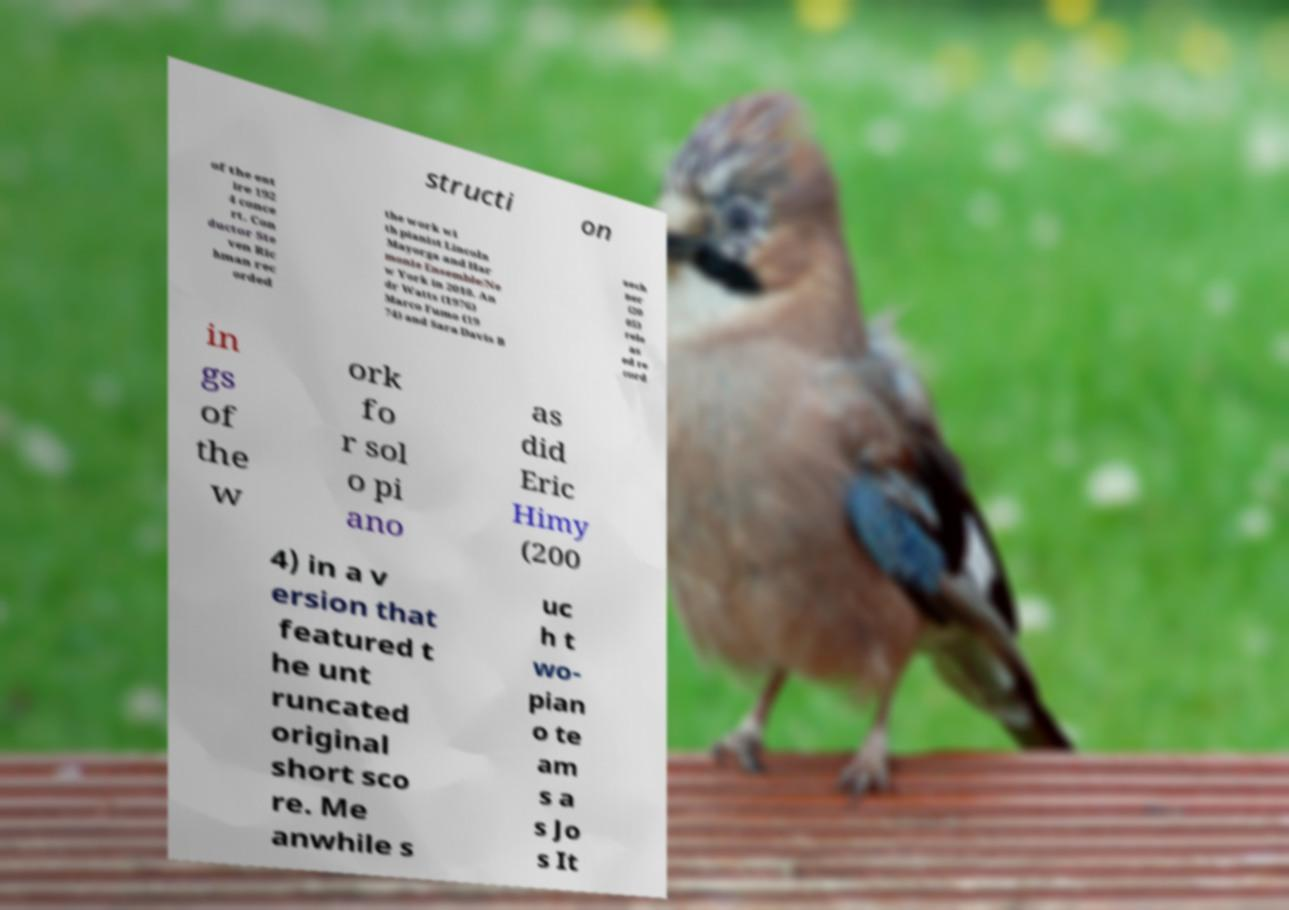Can you read and provide the text displayed in the image?This photo seems to have some interesting text. Can you extract and type it out for me? structi on of the ent ire 192 4 conce rt. Con ductor Ste ven Ric hman rec orded the work wi th pianist Lincoln Mayorga and Har monie Ensemble/Ne w York in 2010. An dr Watts (1976) Marco Fumo (19 74) and Sara Davis B uech ner (20 05) rele as ed re cord in gs of the w ork fo r sol o pi ano as did Eric Himy (200 4) in a v ersion that featured t he unt runcated original short sco re. Me anwhile s uc h t wo- pian o te am s a s Jo s It 